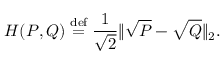Convert formula to latex. <formula><loc_0><loc_0><loc_500><loc_500>H ( P , Q ) \stackrel { d e f } { = } \frac { 1 } \sqrt { 2 } } \| \sqrt { P } - \sqrt { Q } \| _ { 2 } .</formula> 